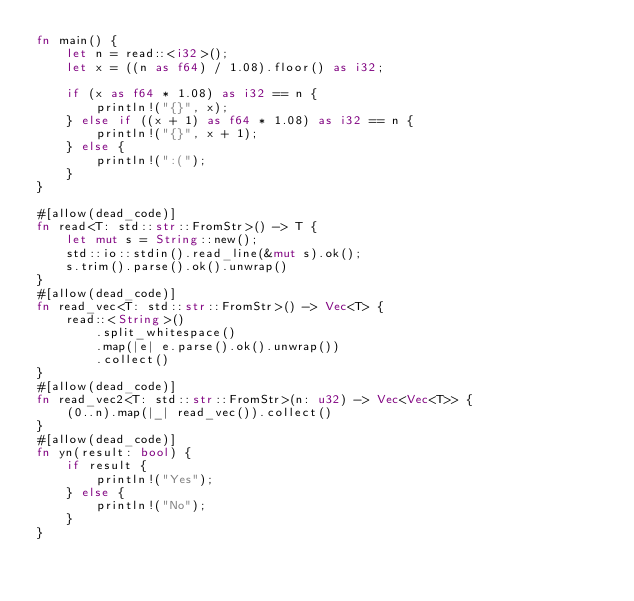<code> <loc_0><loc_0><loc_500><loc_500><_Rust_>fn main() {
    let n = read::<i32>();
    let x = ((n as f64) / 1.08).floor() as i32;

    if (x as f64 * 1.08) as i32 == n {
        println!("{}", x);
    } else if ((x + 1) as f64 * 1.08) as i32 == n {
        println!("{}", x + 1);
    } else {
        println!(":(");
    }
}

#[allow(dead_code)]
fn read<T: std::str::FromStr>() -> T {
    let mut s = String::new();
    std::io::stdin().read_line(&mut s).ok();
    s.trim().parse().ok().unwrap()
}
#[allow(dead_code)]
fn read_vec<T: std::str::FromStr>() -> Vec<T> {
    read::<String>()
        .split_whitespace()
        .map(|e| e.parse().ok().unwrap())
        .collect()
}
#[allow(dead_code)]
fn read_vec2<T: std::str::FromStr>(n: u32) -> Vec<Vec<T>> {
    (0..n).map(|_| read_vec()).collect()
}
#[allow(dead_code)]
fn yn(result: bool) {
    if result {
        println!("Yes");
    } else {
        println!("No");
    }
}
</code> 